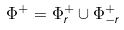Convert formula to latex. <formula><loc_0><loc_0><loc_500><loc_500>\Phi ^ { + } = \Phi ^ { + } _ { r } \cup \Phi ^ { + } _ { - r }</formula> 